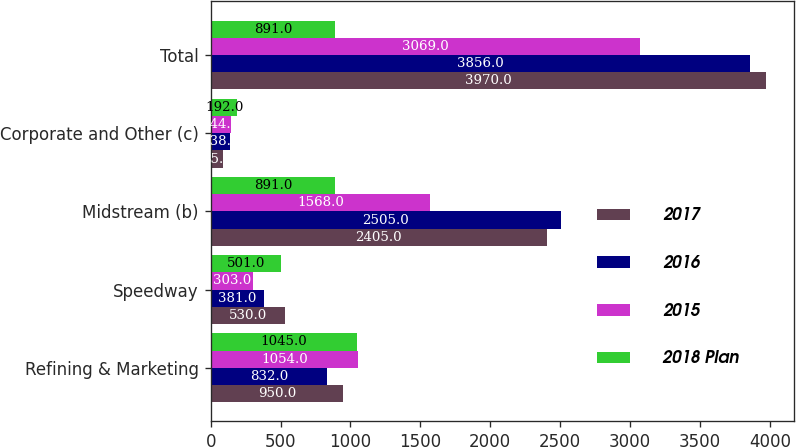<chart> <loc_0><loc_0><loc_500><loc_500><stacked_bar_chart><ecel><fcel>Refining & Marketing<fcel>Speedway<fcel>Midstream (b)<fcel>Corporate and Other (c)<fcel>Total<nl><fcel>2017<fcel>950<fcel>530<fcel>2405<fcel>85<fcel>3970<nl><fcel>2016<fcel>832<fcel>381<fcel>2505<fcel>138<fcel>3856<nl><fcel>2015<fcel>1054<fcel>303<fcel>1568<fcel>144<fcel>3069<nl><fcel>2018 Plan<fcel>1045<fcel>501<fcel>891<fcel>192<fcel>891<nl></chart> 